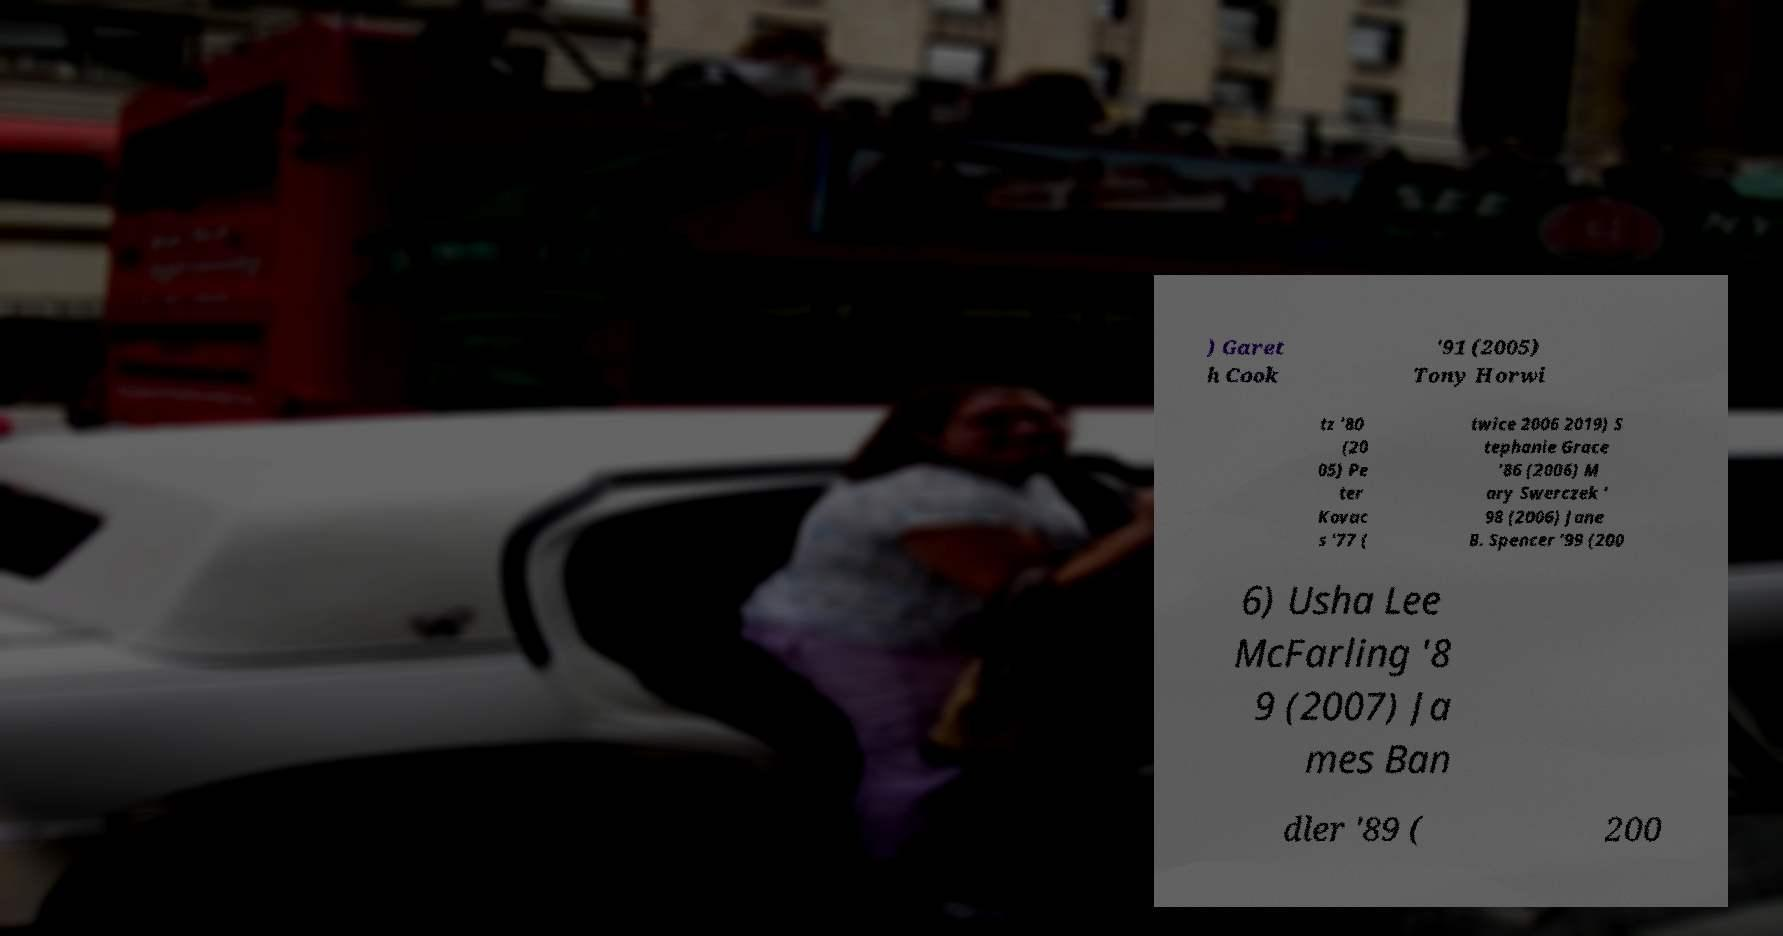There's text embedded in this image that I need extracted. Can you transcribe it verbatim? ) Garet h Cook '91 (2005) Tony Horwi tz '80 (20 05) Pe ter Kovac s '77 ( twice 2006 2019) S tephanie Grace '86 (2006) M ary Swerczek ' 98 (2006) Jane B. Spencer '99 (200 6) Usha Lee McFarling '8 9 (2007) Ja mes Ban dler '89 ( 200 